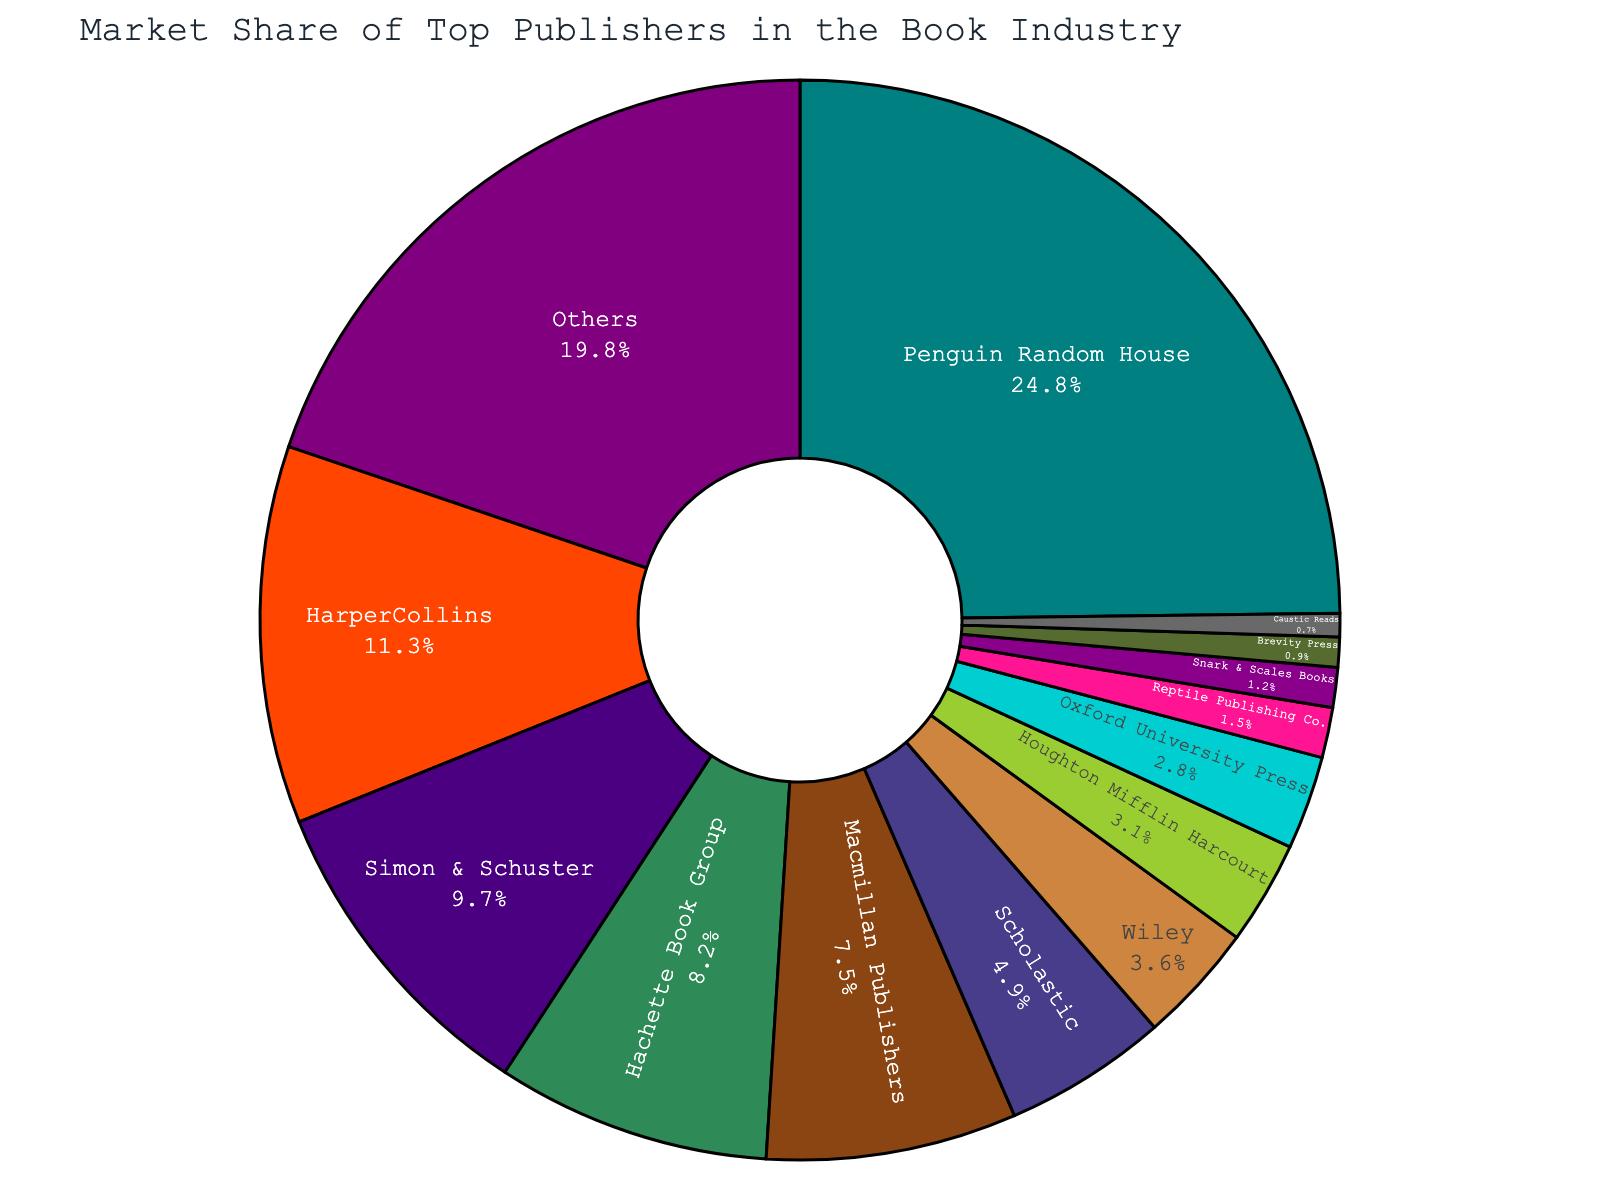What percentage of the market does the smallest publisher hold? To find the smallest publisher by market share, look for the smallest percentage on the pie chart. The smallest value is 0.7%, held by Caustic Reads.
Answer: 0.7% Which publisher has a larger market share: Wiley or Macmillan Publishers? Wiley has a market share of 3.6%, while Macmillan Publishers has a market share of 7.5%. Since 7.5% is greater than 3.6%, Macmillan Publishers has a larger market share.
Answer: Macmillan Publishers What's the combined market share of HarperCollins and Simon & Schuster? HarperCollins has a market share of 11.3% and Simon & Schuster has 9.7%. Adding these two percentages together gives 11.3% + 9.7% = 21%.
Answer: 21% How many publishers have a market share greater than 10%? By inspecting the pie chart, the publishers with more than 10% market share are Penguin Random House (24.8%) and HarperCollins (11.3%). This makes a total of 2 publishers.
Answer: 2 Which publisher has a higher market share: Reptile Publishing Co. or Snark & Scales Books? Reptile Publishing Co. has a market share of 1.5%, while Snark & Scales Books has a market share of 1.2%. Since 1.5% is greater than 1.2%, Reptile Publishing Co. has the higher market share.
Answer: Reptile Publishing Co What's the total market share of publishers with less than 5% each? The publishers with less than 5% market share are Scholastic (4.9%), Wiley (3.6%), Houghton Mifflin Harcourt (3.1%), Oxford University Press (2.8%), Reptile Publishing Co. (1.5%), Snark & Scales Books (1.2%), Brevity Press (0.9%), and Caustic Reads (0.7%). Adding these values gives 4.9% + 3.6% + 3.1% + 2.8% + 1.5% + 1.2% + 0.9% + 0.7% = 18.7%.
Answer: 18.7% Which segment is displayed in teal? By looking at the pie chart's color legend, the segment shown in teal represents Penguin Random House.
Answer: Penguin Random House What is the market share difference between the highest and lowest publishers? The highest market share is Penguin Random House with 24.8%, and the lowest is Caustic Reads with 0.7%. The difference is 24.8% - 0.7% = 24.1%.
Answer: 24.1% 